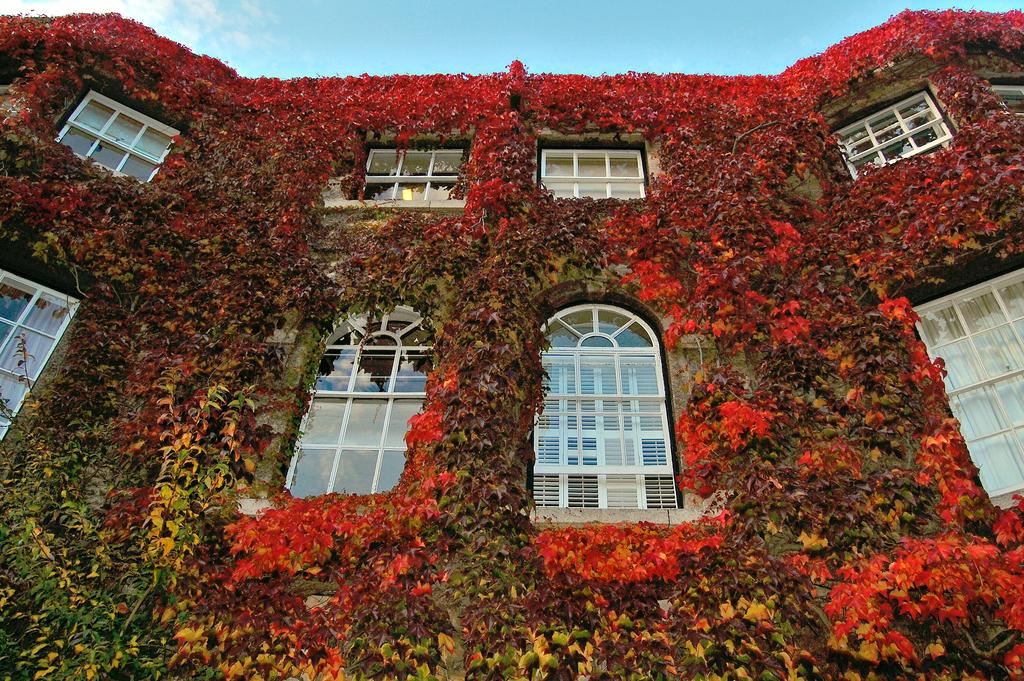What structure is depicted in the image? There is a building in the image. What type of vegetation is growing on the building? There are creepers on the building. What can be seen in the background of the image? The sky is visible in the background of the image. What is the condition of the sky in the image? Clouds are present in the sky. What type of bun is being used to care for the horse in the image? There is no bun or horse present in the image; it features a building with creepers and a sky with clouds. 